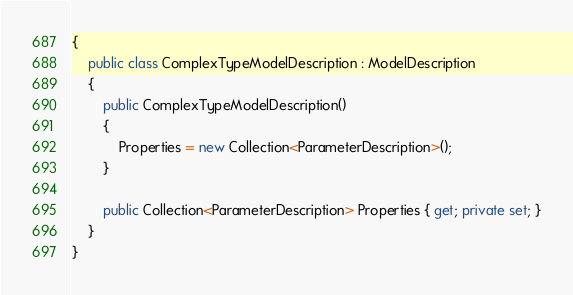<code> <loc_0><loc_0><loc_500><loc_500><_C#_>{
    public class ComplexTypeModelDescription : ModelDescription
    {
        public ComplexTypeModelDescription()
        {
            Properties = new Collection<ParameterDescription>();
        }

        public Collection<ParameterDescription> Properties { get; private set; }
    }
}</code> 